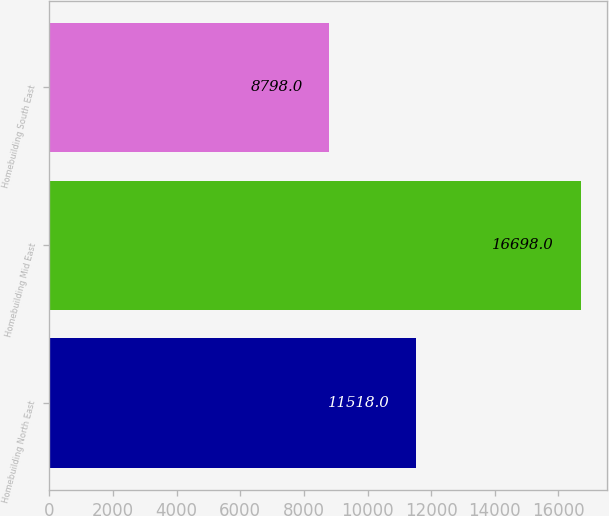Convert chart to OTSL. <chart><loc_0><loc_0><loc_500><loc_500><bar_chart><fcel>Homebuilding North East<fcel>Homebuilding Mid East<fcel>Homebuilding South East<nl><fcel>11518<fcel>16698<fcel>8798<nl></chart> 